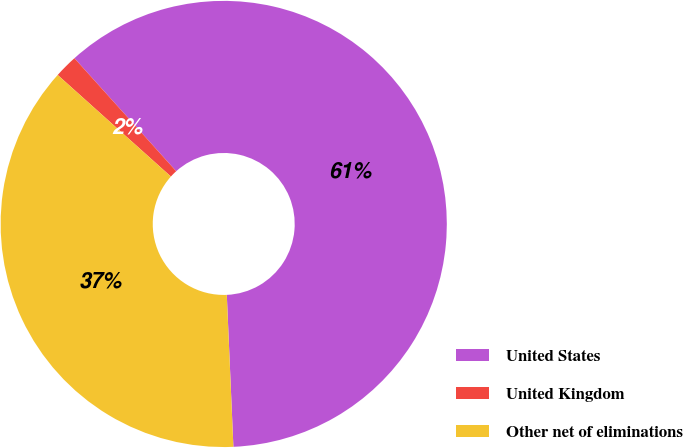Convert chart. <chart><loc_0><loc_0><loc_500><loc_500><pie_chart><fcel>United States<fcel>United Kingdom<fcel>Other net of eliminations<nl><fcel>60.98%<fcel>1.69%<fcel>37.33%<nl></chart> 